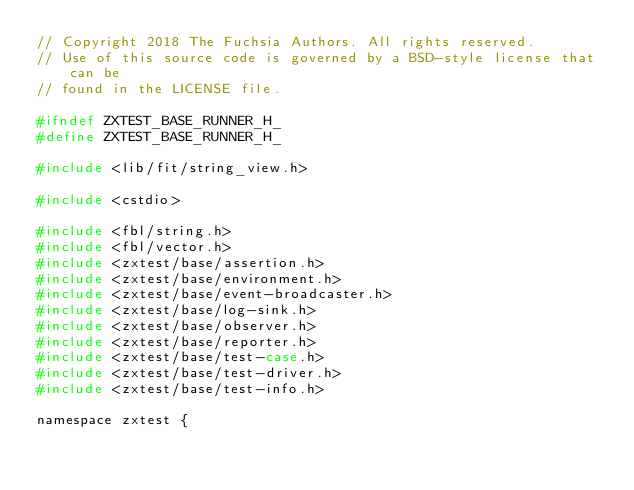<code> <loc_0><loc_0><loc_500><loc_500><_C_>// Copyright 2018 The Fuchsia Authors. All rights reserved.
// Use of this source code is governed by a BSD-style license that can be
// found in the LICENSE file.

#ifndef ZXTEST_BASE_RUNNER_H_
#define ZXTEST_BASE_RUNNER_H_

#include <lib/fit/string_view.h>

#include <cstdio>

#include <fbl/string.h>
#include <fbl/vector.h>
#include <zxtest/base/assertion.h>
#include <zxtest/base/environment.h>
#include <zxtest/base/event-broadcaster.h>
#include <zxtest/base/log-sink.h>
#include <zxtest/base/observer.h>
#include <zxtest/base/reporter.h>
#include <zxtest/base/test-case.h>
#include <zxtest/base/test-driver.h>
#include <zxtest/base/test-info.h>

namespace zxtest {
</code> 